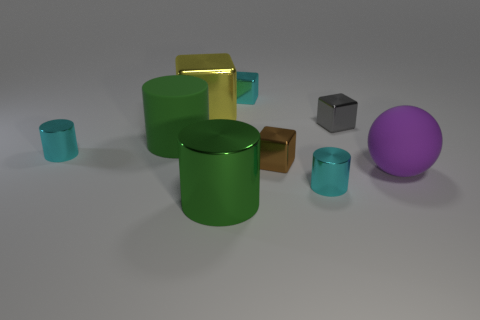Is the color of the rubber sphere the same as the matte cylinder?
Your response must be concise. No. How many things are either blocks that are in front of the large yellow block or yellow shiny things?
Your answer should be compact. 3. There is a small cyan cylinder that is behind the tiny cyan metal cylinder in front of the brown object; how many gray things are in front of it?
Keep it short and to the point. 0. Is there any other thing that is the same size as the gray cube?
Give a very brief answer. Yes. What shape is the matte thing that is in front of the large cylinder behind the small cylinder that is behind the big sphere?
Ensure brevity in your answer.  Sphere. How many other objects are there of the same color as the big metal cylinder?
Provide a short and direct response. 1. What is the shape of the gray thing that is on the right side of the cyan thing in front of the brown thing?
Make the answer very short. Cube. How many rubber objects are on the left side of the small brown metallic object?
Your answer should be very brief. 1. Is there a green thing made of the same material as the brown cube?
Make the answer very short. Yes. What material is the brown object that is the same size as the gray metallic cube?
Your response must be concise. Metal. 